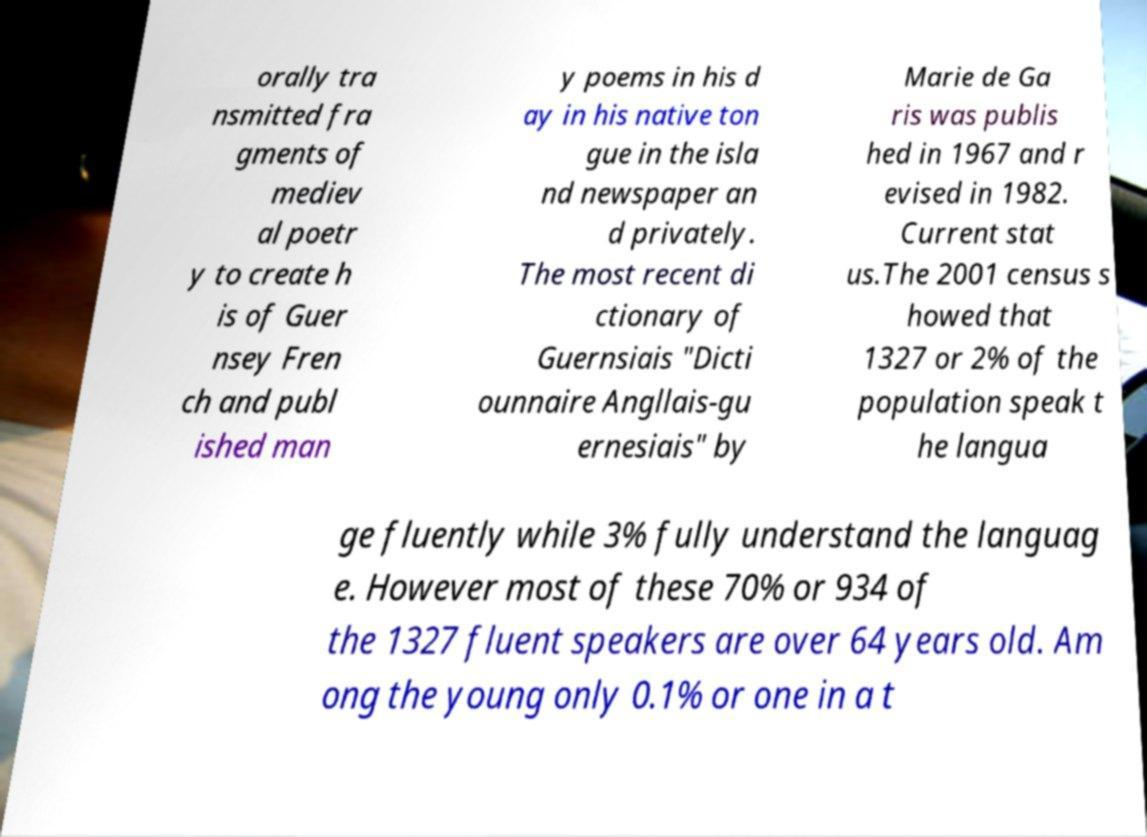Can you accurately transcribe the text from the provided image for me? orally tra nsmitted fra gments of mediev al poetr y to create h is of Guer nsey Fren ch and publ ished man y poems in his d ay in his native ton gue in the isla nd newspaper an d privately. The most recent di ctionary of Guernsiais "Dicti ounnaire Angllais-gu ernesiais" by Marie de Ga ris was publis hed in 1967 and r evised in 1982. Current stat us.The 2001 census s howed that 1327 or 2% of the population speak t he langua ge fluently while 3% fully understand the languag e. However most of these 70% or 934 of the 1327 fluent speakers are over 64 years old. Am ong the young only 0.1% or one in a t 